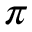Convert formula to latex. <formula><loc_0><loc_0><loc_500><loc_500>\pi</formula> 